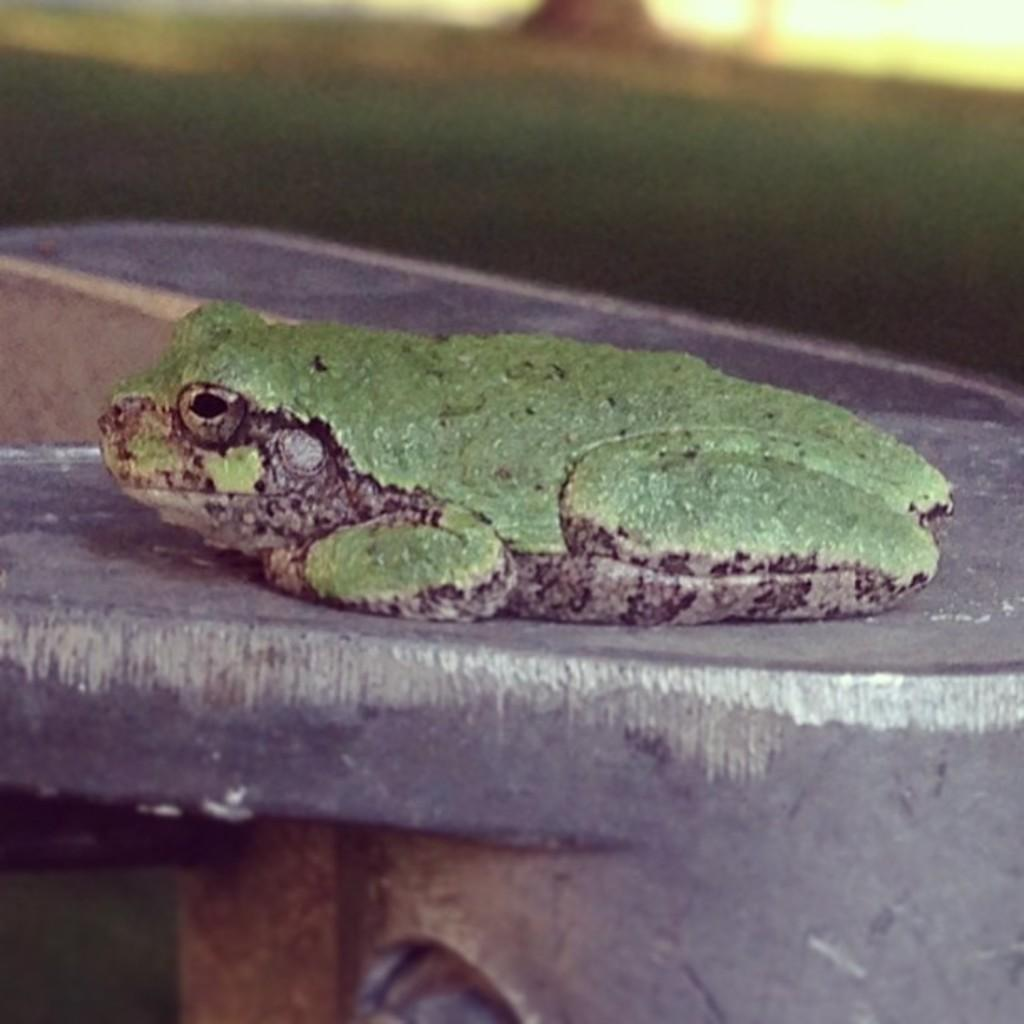What animal is present in the image? There is a frog in the image. What is the frog sitting on? The frog is on an object. What type of environment can be seen in the background of the image? The background of the image includes grass. How would you describe the clarity of the background in the image? The background is blurry. What type of calendar is hanging on the bridge in the image? There is no calendar or bridge present in the image; it features a frog on an object with a blurry grassy background. 